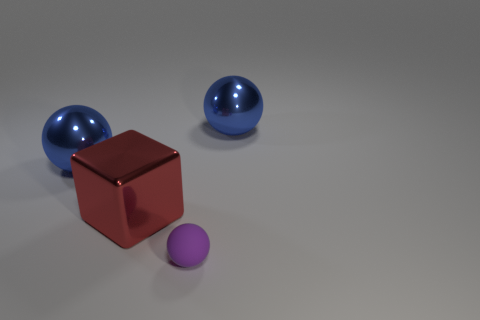Is there any other thing that is the same size as the purple sphere?
Give a very brief answer. No. Is there anything else that has the same shape as the big red object?
Provide a short and direct response. No. How many big metal things are both behind the large cube and left of the purple rubber ball?
Your response must be concise. 1. Is there a shiny ball of the same color as the big cube?
Ensure brevity in your answer.  No. Are there any tiny purple spheres behind the large red metallic thing?
Your answer should be compact. No. Is the material of the object that is right of the purple rubber thing the same as the large blue object to the left of the small purple matte ball?
Provide a short and direct response. Yes. How many blue metallic balls have the same size as the red cube?
Give a very brief answer. 2. What is the small purple thing that is on the right side of the red metallic object made of?
Provide a succinct answer. Rubber. How many other large objects have the same shape as the purple object?
Your answer should be compact. 2. There is a large blue metal object that is in front of the blue object that is right of the big blue sphere to the left of the large red metallic thing; what shape is it?
Make the answer very short. Sphere. 